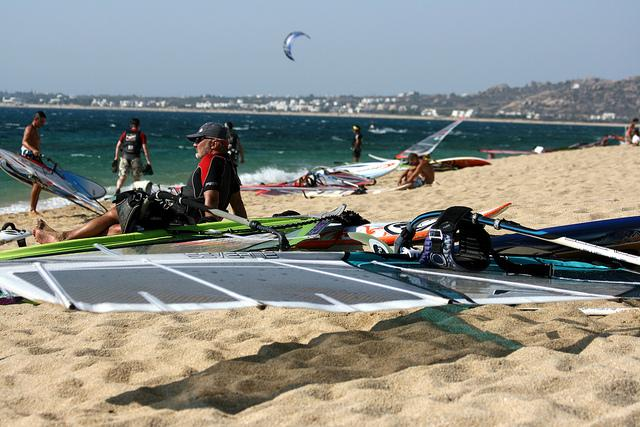Where is the person holding the sail seen here standing? beach 